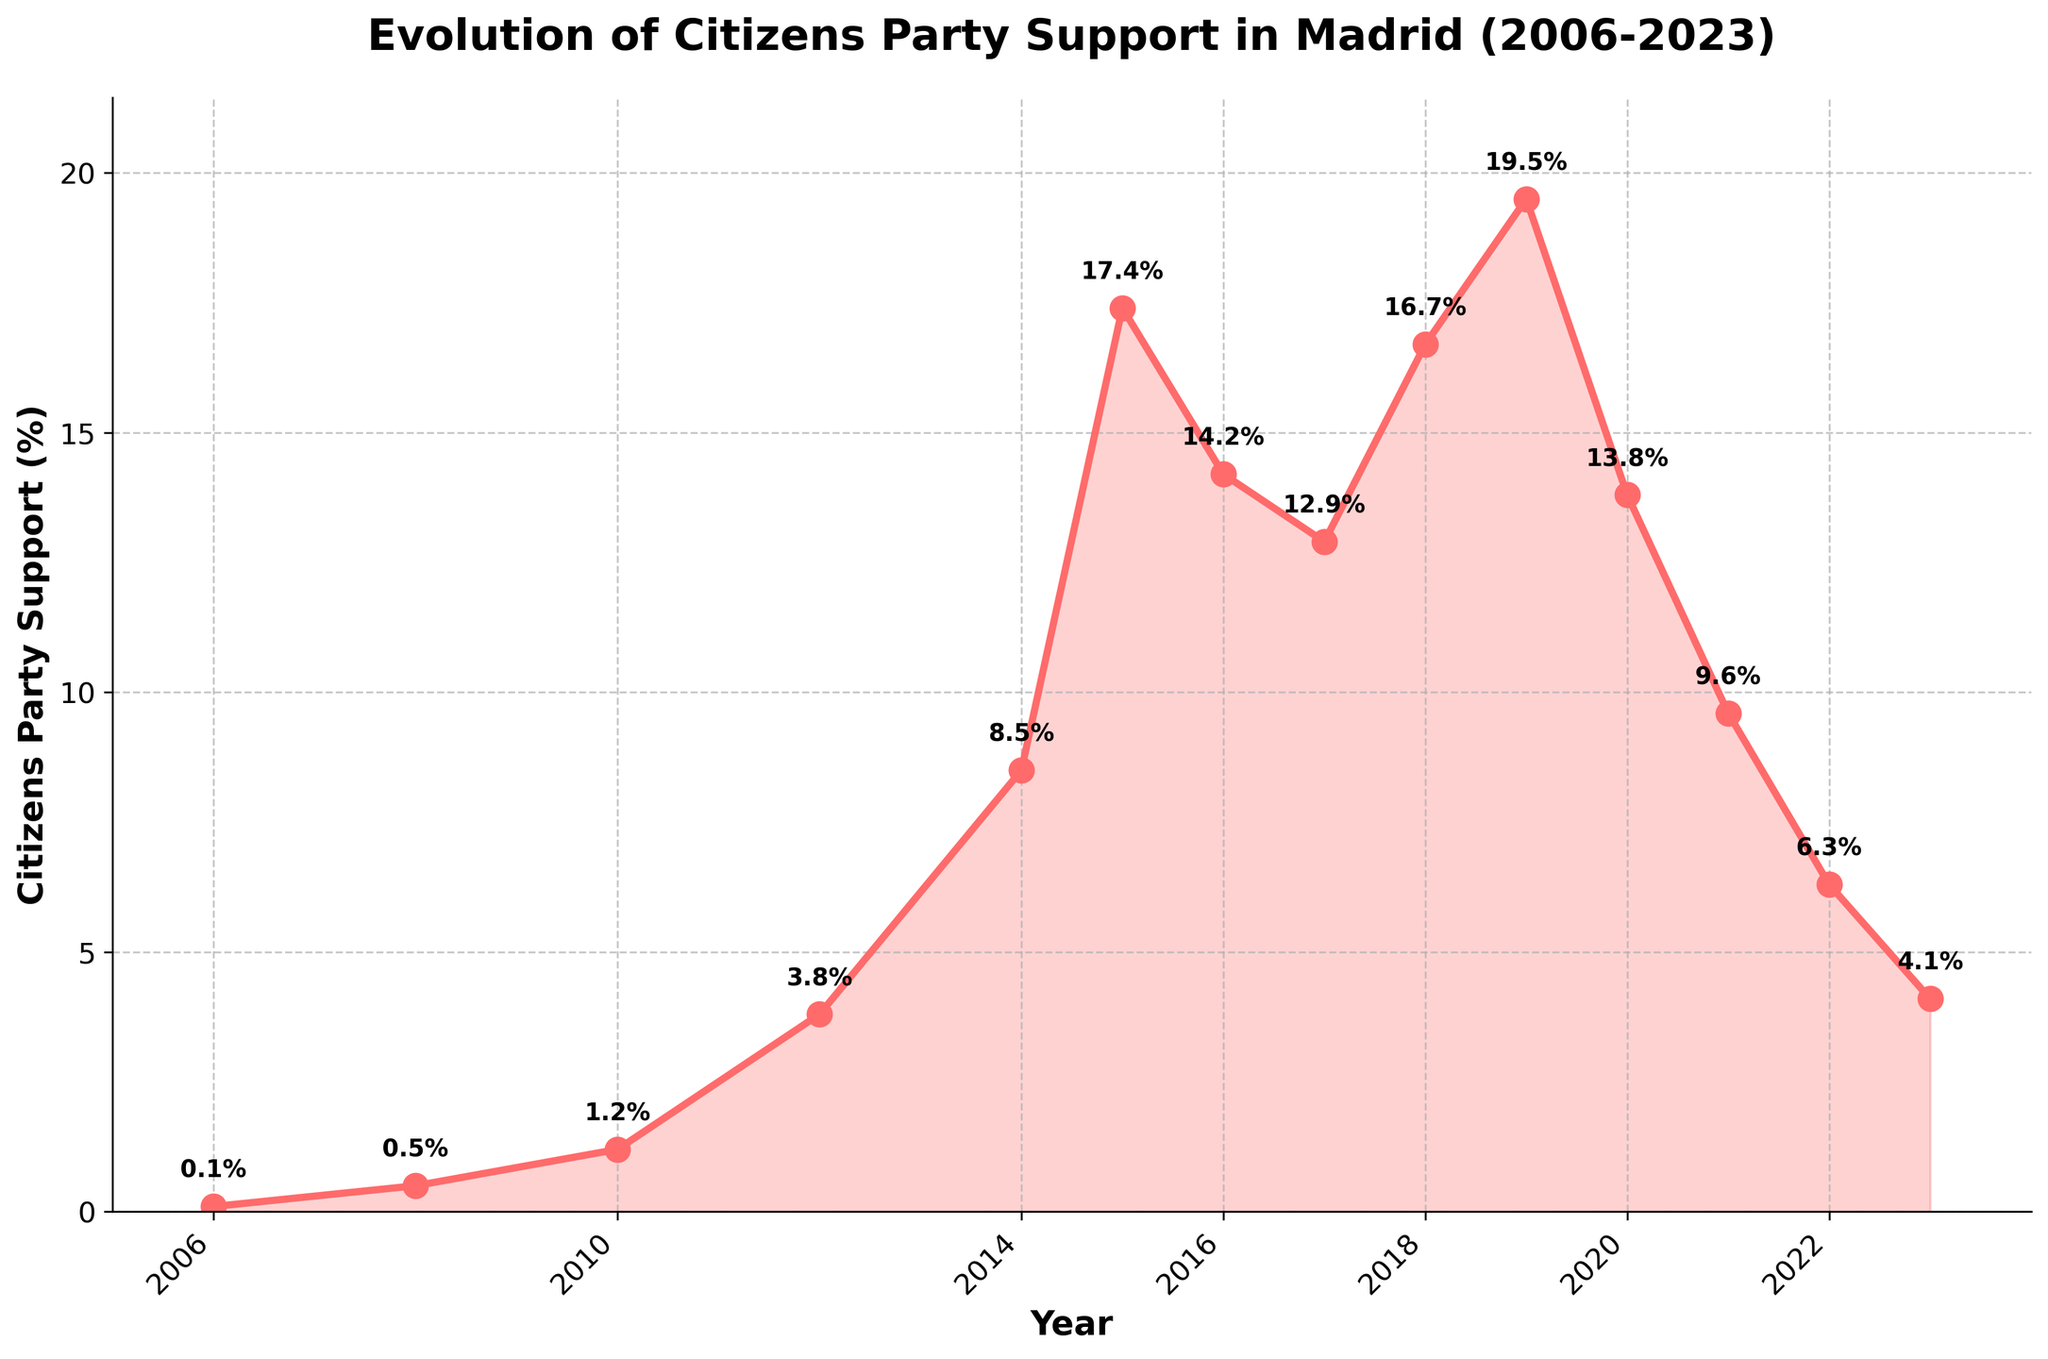How has the support for the Citizens party in Madrid changed from 2006 to 2016? The plot shows an increase in support from 0.1% in 2006 to a peak of 17.4% in 2015, followed by a slight decline to 14.2% in 2016.
Answer: Increased initially, peaked, then declined slightly What is the highest level of support the Citizens party reached, and in which year? The largest peak in the chart is in 2019, at 19.5%.
Answer: 19.5% in 2019 How does the support in 2023 compare to the support in 2014? In 2014, support was 8.5%, and in 2023, it was 4.1%, so the support in 2023 is lower than in 2014.
Answer: 2023 is lower than 2014 During which period did the Citizens party experience the most significant growth in support? The plot shows the most rapid increase between 2010 (1.2%) and 2015 (17.4%), which is an increase of 16.2 percentage points.
Answer: Between 2010 and 2015 Which year saw the largest drop in support? The decline from 2019 (19.5%) to 2020 (13.8%) is the most significant drop, amounting to 5.7 percentage points.
Answer: From 2019 to 2020 What is the average support for the Citizens party over the years shown? Sum all the percentages given (17 data points) and divide by 17: (0.1 + 0.5 + 1.2 + 3.8 + 8.5 + 17.4 + 14.2 + 12.9 + 16.7 + 19.5 + 13.8 + 9.6 + 6.3 + 4.1) / 14 = 8.96%.
Answer: 8.96% In which year was the support exactly half of what it was in 2019? Half of 19.5% is 9.75%. The closest to this is 2021, which has a support of 9.6%.
Answer: 2021 What visual features help to differentiate periods of growth from periods of decline in the Citizens party’s support? The line’s slope indicates growth (upward slope) or decline (downward slope). Marker annotations for each year indicate specific values, and the filled area visually emphasizes the trends.
Answer: Line slope and filled area How many years did the party’s support stay above 10%? The support stayed above 10% from 2015 to 2019 and also part of 2016 and 2017, totaling 4 years.
Answer: 4 years What was the trend in support levels from 2020 to 2023? The support steadily declined each year from 13.8% in 2020 to 4.1% in 2023.
Answer: Steadily declined 